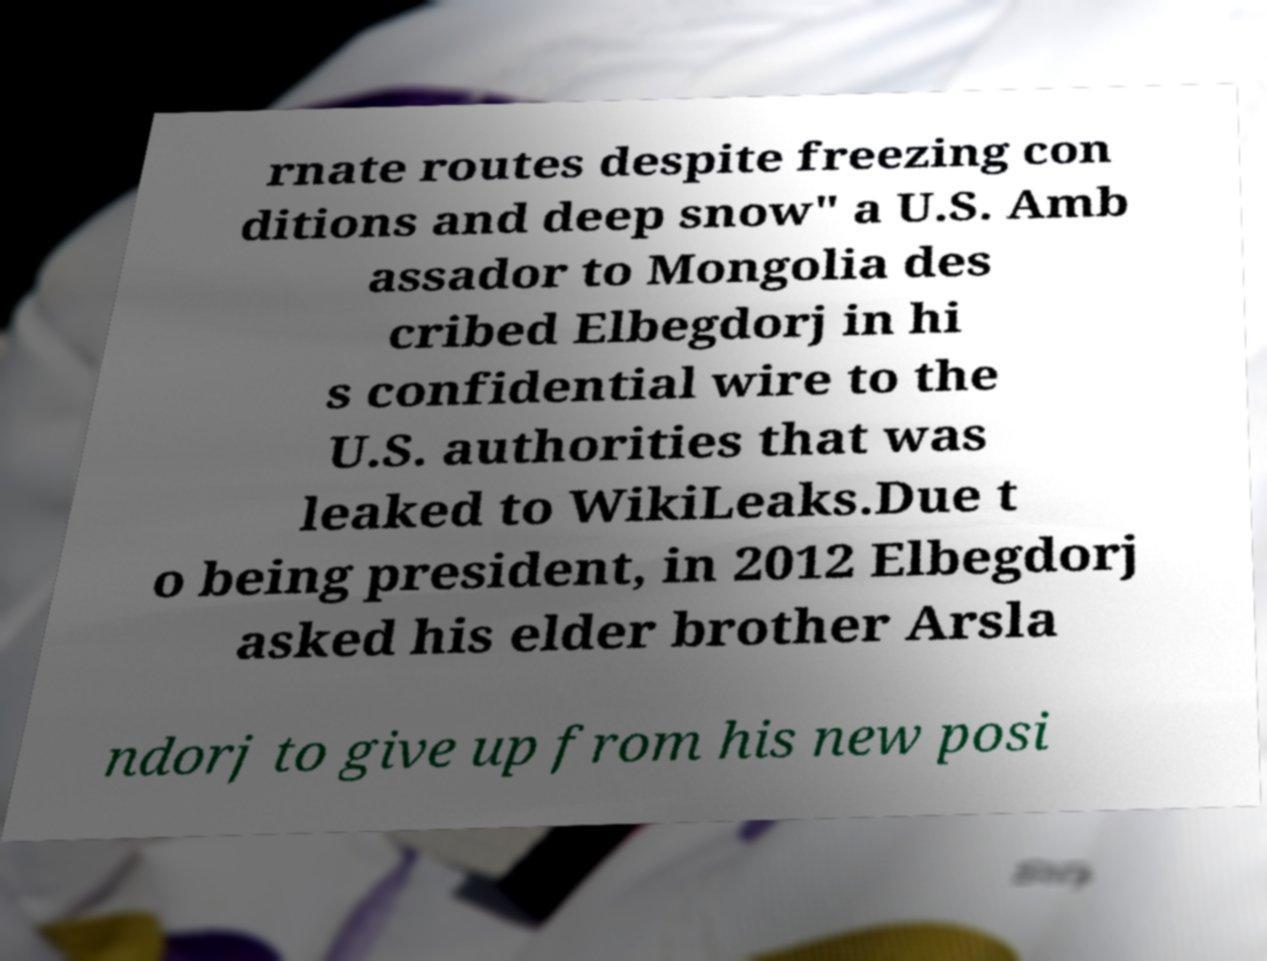Please identify and transcribe the text found in this image. rnate routes despite freezing con ditions and deep snow" a U.S. Amb assador to Mongolia des cribed Elbegdorj in hi s confidential wire to the U.S. authorities that was leaked to WikiLeaks.Due t o being president, in 2012 Elbegdorj asked his elder brother Arsla ndorj to give up from his new posi 